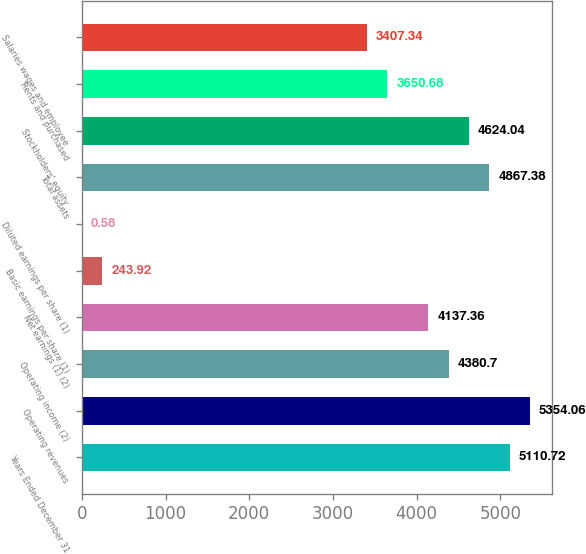<chart> <loc_0><loc_0><loc_500><loc_500><bar_chart><fcel>Years Ended December 31<fcel>Operating revenues<fcel>Operating income (2)<fcel>Net earnings (1) (2)<fcel>Basic earnings per share (1)<fcel>Diluted earnings per share (1)<fcel>Total assets<fcel>Stockholders' equity<fcel>Rents and purchased<fcel>Salaries wages and employee<nl><fcel>5110.72<fcel>5354.06<fcel>4380.7<fcel>4137.36<fcel>243.92<fcel>0.58<fcel>4867.38<fcel>4624.04<fcel>3650.68<fcel>3407.34<nl></chart> 